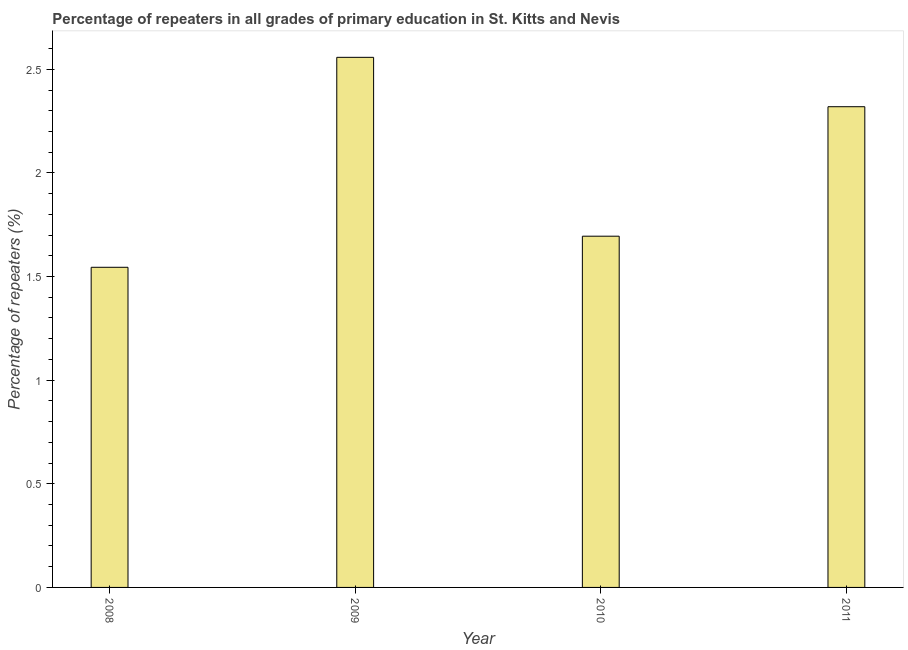Does the graph contain any zero values?
Your answer should be very brief. No. Does the graph contain grids?
Ensure brevity in your answer.  No. What is the title of the graph?
Give a very brief answer. Percentage of repeaters in all grades of primary education in St. Kitts and Nevis. What is the label or title of the X-axis?
Your answer should be very brief. Year. What is the label or title of the Y-axis?
Keep it short and to the point. Percentage of repeaters (%). What is the percentage of repeaters in primary education in 2009?
Give a very brief answer. 2.56. Across all years, what is the maximum percentage of repeaters in primary education?
Provide a succinct answer. 2.56. Across all years, what is the minimum percentage of repeaters in primary education?
Give a very brief answer. 1.54. In which year was the percentage of repeaters in primary education maximum?
Your answer should be very brief. 2009. What is the sum of the percentage of repeaters in primary education?
Offer a very short reply. 8.12. What is the difference between the percentage of repeaters in primary education in 2008 and 2011?
Provide a succinct answer. -0.78. What is the average percentage of repeaters in primary education per year?
Keep it short and to the point. 2.03. What is the median percentage of repeaters in primary education?
Give a very brief answer. 2.01. In how many years, is the percentage of repeaters in primary education greater than 1.6 %?
Your answer should be very brief. 3. Do a majority of the years between 2008 and 2009 (inclusive) have percentage of repeaters in primary education greater than 0.1 %?
Your response must be concise. Yes. What is the ratio of the percentage of repeaters in primary education in 2009 to that in 2011?
Ensure brevity in your answer.  1.1. What is the difference between the highest and the second highest percentage of repeaters in primary education?
Make the answer very short. 0.24. In how many years, is the percentage of repeaters in primary education greater than the average percentage of repeaters in primary education taken over all years?
Give a very brief answer. 2. How many bars are there?
Make the answer very short. 4. Are the values on the major ticks of Y-axis written in scientific E-notation?
Keep it short and to the point. No. What is the Percentage of repeaters (%) of 2008?
Provide a succinct answer. 1.54. What is the Percentage of repeaters (%) in 2009?
Ensure brevity in your answer.  2.56. What is the Percentage of repeaters (%) of 2010?
Give a very brief answer. 1.69. What is the Percentage of repeaters (%) in 2011?
Provide a succinct answer. 2.32. What is the difference between the Percentage of repeaters (%) in 2008 and 2009?
Keep it short and to the point. -1.01. What is the difference between the Percentage of repeaters (%) in 2008 and 2010?
Your answer should be very brief. -0.15. What is the difference between the Percentage of repeaters (%) in 2008 and 2011?
Your answer should be very brief. -0.77. What is the difference between the Percentage of repeaters (%) in 2009 and 2010?
Ensure brevity in your answer.  0.86. What is the difference between the Percentage of repeaters (%) in 2009 and 2011?
Keep it short and to the point. 0.24. What is the difference between the Percentage of repeaters (%) in 2010 and 2011?
Provide a short and direct response. -0.62. What is the ratio of the Percentage of repeaters (%) in 2008 to that in 2009?
Your response must be concise. 0.6. What is the ratio of the Percentage of repeaters (%) in 2008 to that in 2010?
Your answer should be compact. 0.91. What is the ratio of the Percentage of repeaters (%) in 2008 to that in 2011?
Make the answer very short. 0.67. What is the ratio of the Percentage of repeaters (%) in 2009 to that in 2010?
Make the answer very short. 1.51. What is the ratio of the Percentage of repeaters (%) in 2009 to that in 2011?
Ensure brevity in your answer.  1.1. What is the ratio of the Percentage of repeaters (%) in 2010 to that in 2011?
Ensure brevity in your answer.  0.73. 